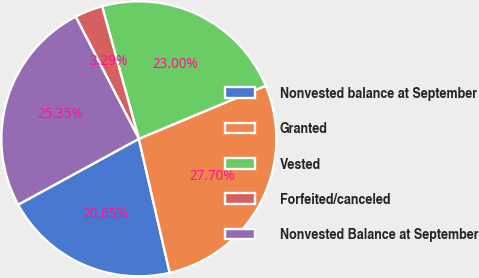<chart> <loc_0><loc_0><loc_500><loc_500><pie_chart><fcel>Nonvested balance at September<fcel>Granted<fcel>Vested<fcel>Forfeited/canceled<fcel>Nonvested Balance at September<nl><fcel>20.65%<fcel>27.7%<fcel>23.0%<fcel>3.29%<fcel>25.35%<nl></chart> 